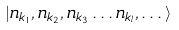Convert formula to latex. <formula><loc_0><loc_0><loc_500><loc_500>| n _ { { k } _ { 1 } } , n _ { { k } _ { 2 } } , n _ { { k } _ { 3 } } \dots n _ { { k } _ { l } } , \dots \rangle</formula> 